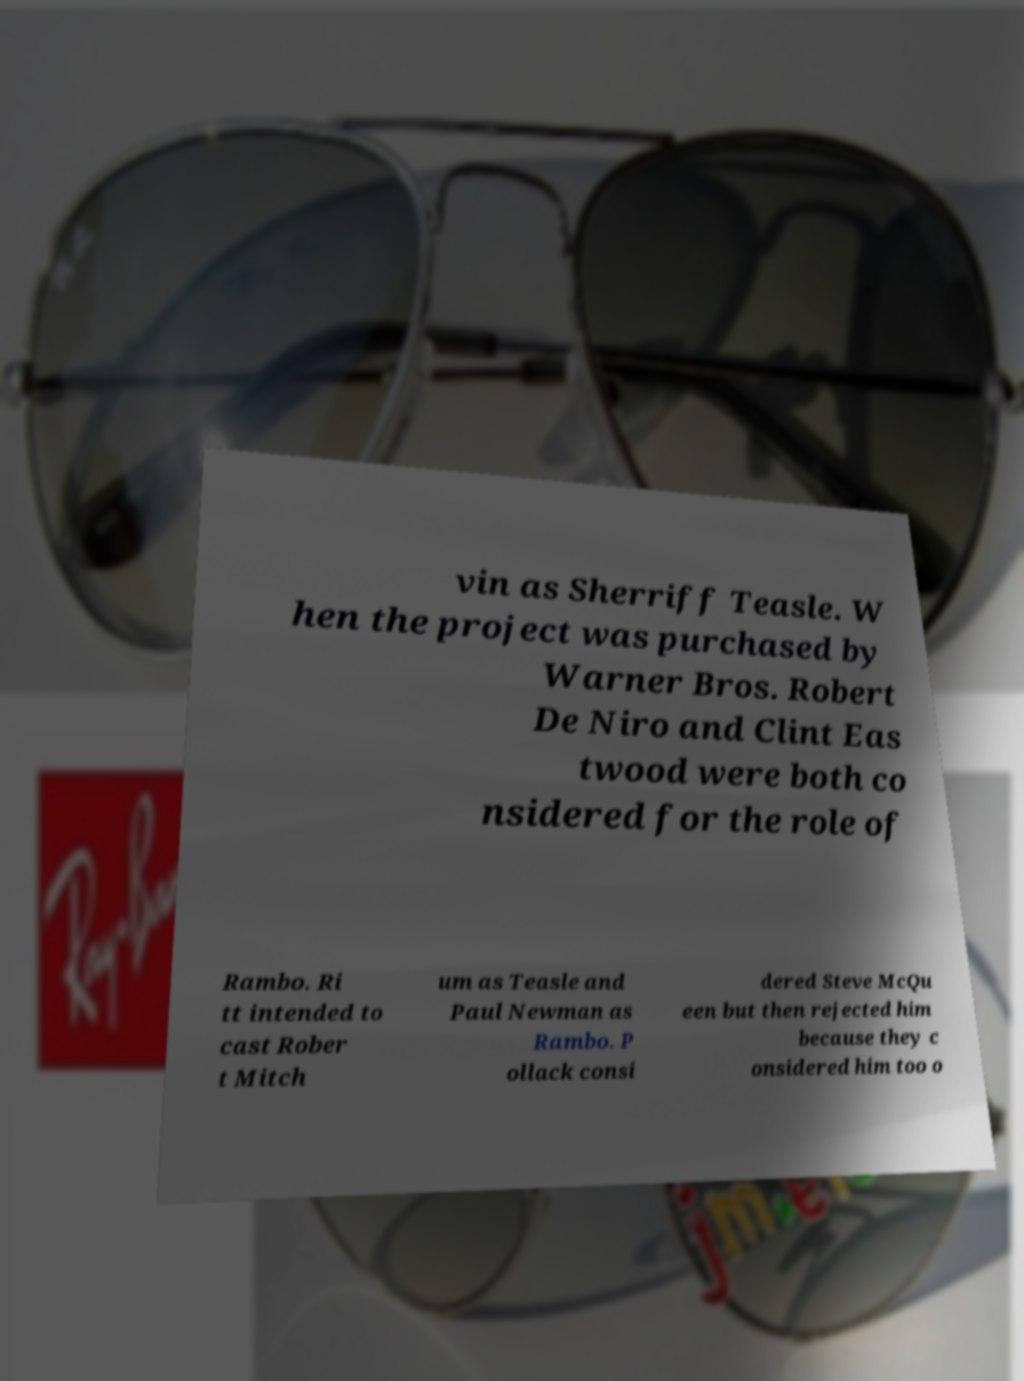For documentation purposes, I need the text within this image transcribed. Could you provide that? vin as Sherriff Teasle. W hen the project was purchased by Warner Bros. Robert De Niro and Clint Eas twood were both co nsidered for the role of Rambo. Ri tt intended to cast Rober t Mitch um as Teasle and Paul Newman as Rambo. P ollack consi dered Steve McQu een but then rejected him because they c onsidered him too o 